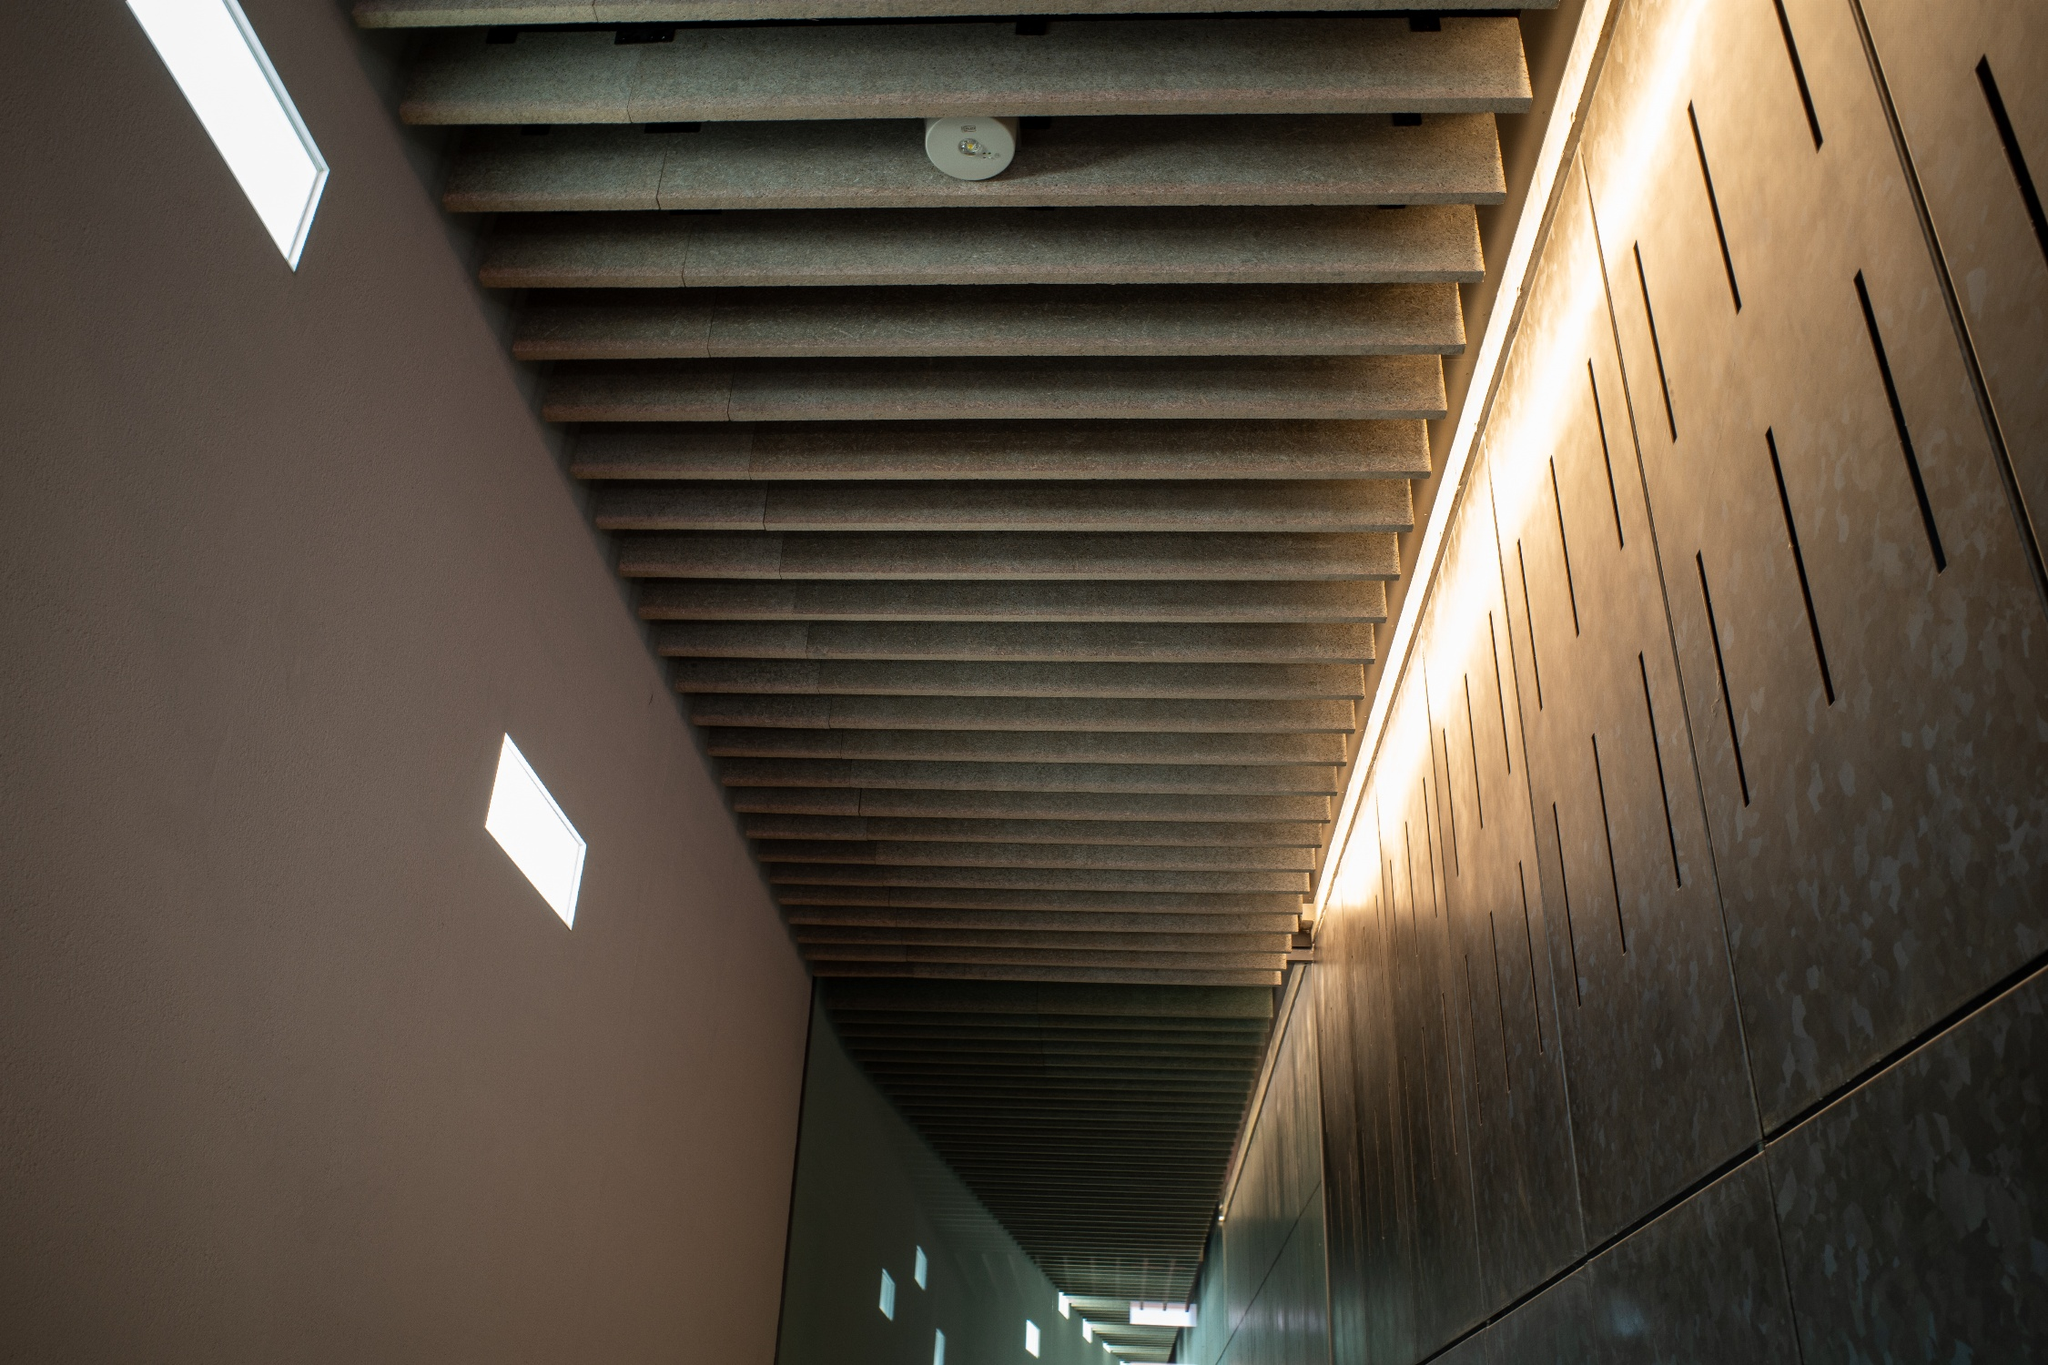What details suggest the intended atmosphere of the space? The serene atmosphere of this hallway is meticulously crafted through various architectural elements. The soft brown ribbed ceiling, combined with square recessed lights, offers a warm and inviting glow. The choice of light-colored stone for the walls and floor, punctuated by small rectangular windows, ensures a gentle infusion of natural light, avoiding any harsh contrasts. The minimalistic design and clean lines further contribute to the tranquil and almost meditative ambiance, encouraging a sense of calm and reflection as one moves through the space. 